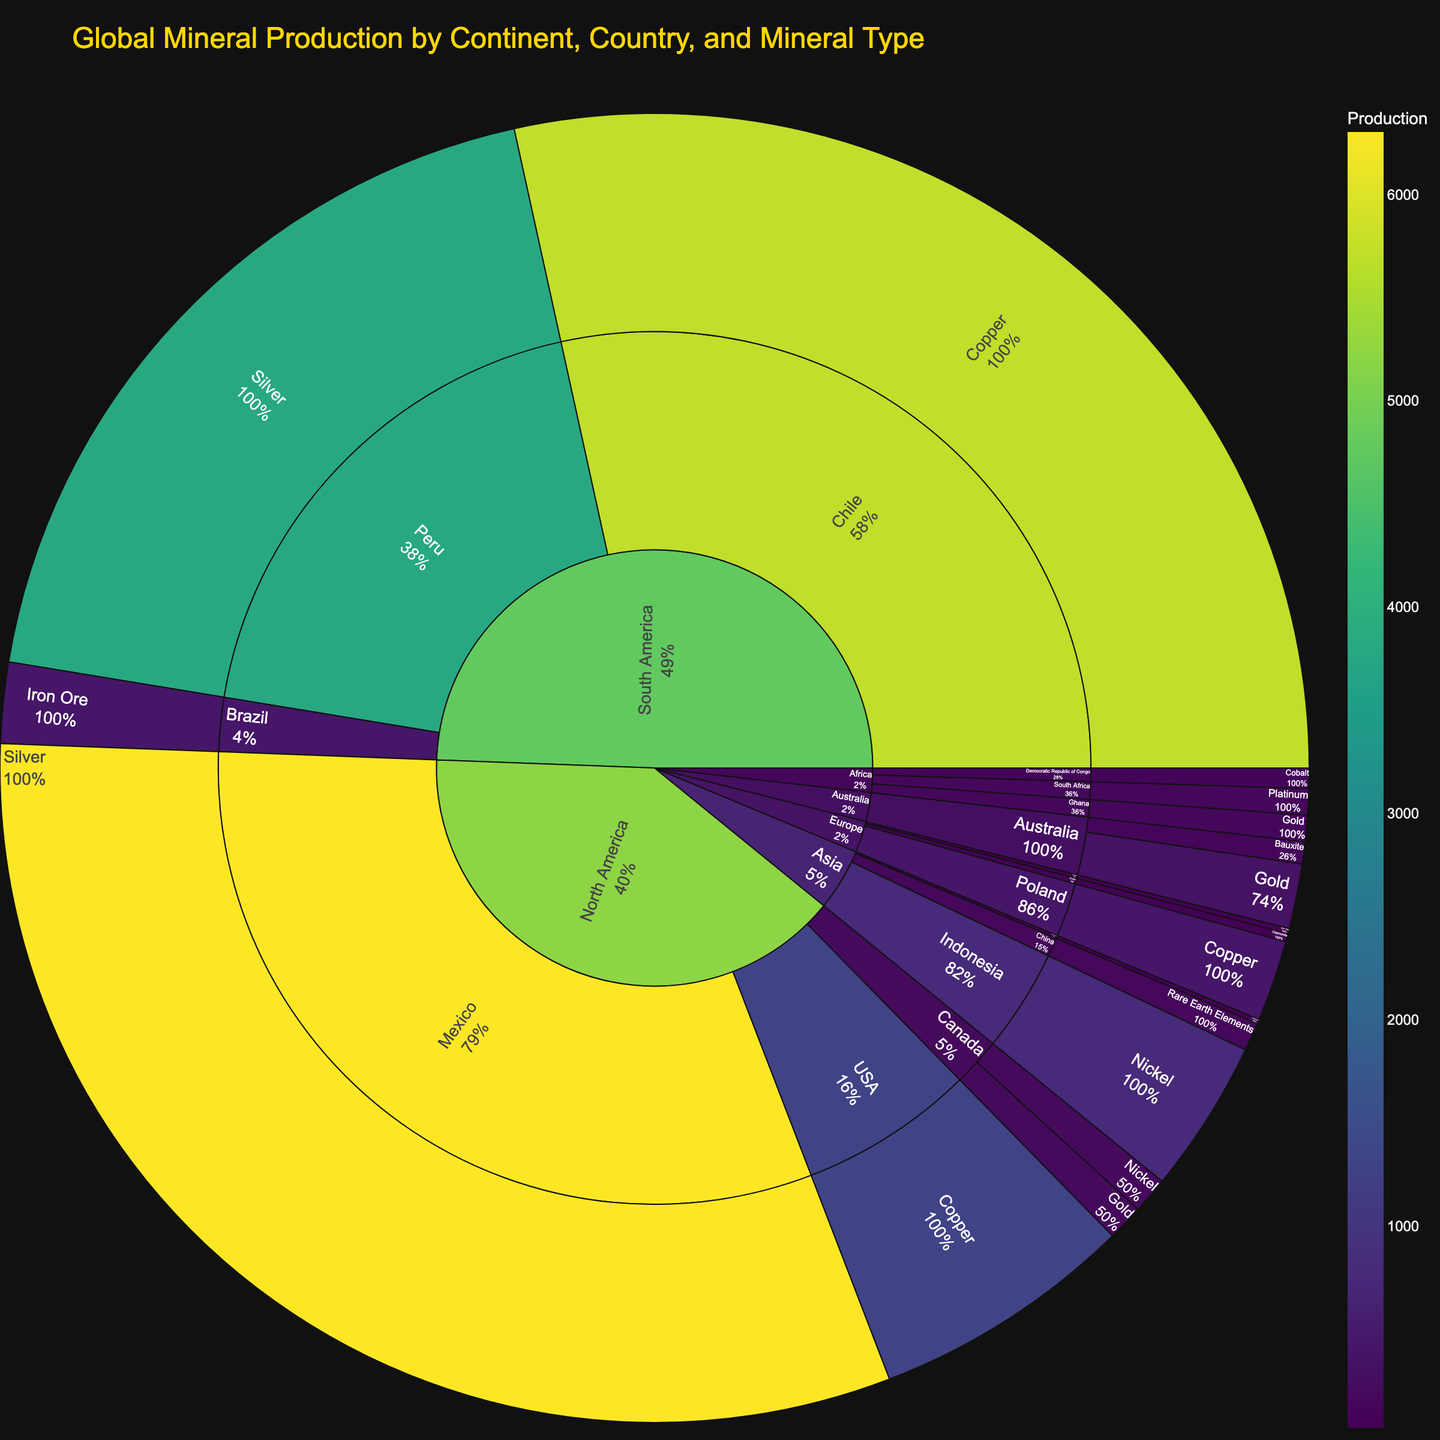What's the title of the Sunburst Plot? The title of the Sunburst Plot is usually displayed at the top of the chart. In this figure, the title is "Global Mineral Production by Continent, Country, and Mineral Type".
Answer: Global Mineral Production by Continent, Country, and Mineral Type Which continent has the highest total mineral production? To determine the continent with the highest total mineral production, observe the outermost ring of the Sunburst Plot and note the segment with the largest area. North America has the brightest and largest segment.
Answer: North America What mineral type has the highest production in South America? To find the highest produced mineral in South America, look at the segments branching from South America. Notice the copper segment is the largest and brightest.
Answer: Copper Compare the gold production of Canada to Australia's gold production. Which country produces more? To compare the gold production, locate the segments for gold in Canada and Australia on the Sunburst Plot. Canada's gold segment is smaller and less bright than Australia's.
Answer: Australia What is the total production of Nickel? To find the total production of Nickel, sum the values from all Nickel-producing countries. Canada produces 180 and Indonesia produces 760. So, 180 + 760 = 940.
Answer: 940 Which country in Asia has the highest production of a rare mineral type, and what is that mineral? In Asia, identify the countries and their minerals and their respective production values. China has the highest production for Rare Earth Elements.
Answer: China, Rare Earth Elements How does the silver production in Mexico compare to that in Peru? Compare the silver production segments of Mexico and Peru. Mexico’s segment is larger and brighter, indicating higher production than Peru.
Answer: Mexico What is the least produced mineral in Africa, and which country produces it? Examine the segments corresponding to minerals produced in Africa. The smallest and least bright segment is for Cobalt in the Democratic Republic of Congo.
Answer: Cobalt, Democratic Republic of Congo Which country in Europe produces the largest amount of Iron Ore? Within Europe, inspect the Iron Ore segments stemming from different countries. The largest segment belongs to Sweden.
Answer: Sweden What is the total mineral production of all countries in Europe combined? Sum the production values of all European countries listed: Russia (41), Sweden (26), and Poland (400). So, 41 + 26 + 400 = 467.
Answer: 467 